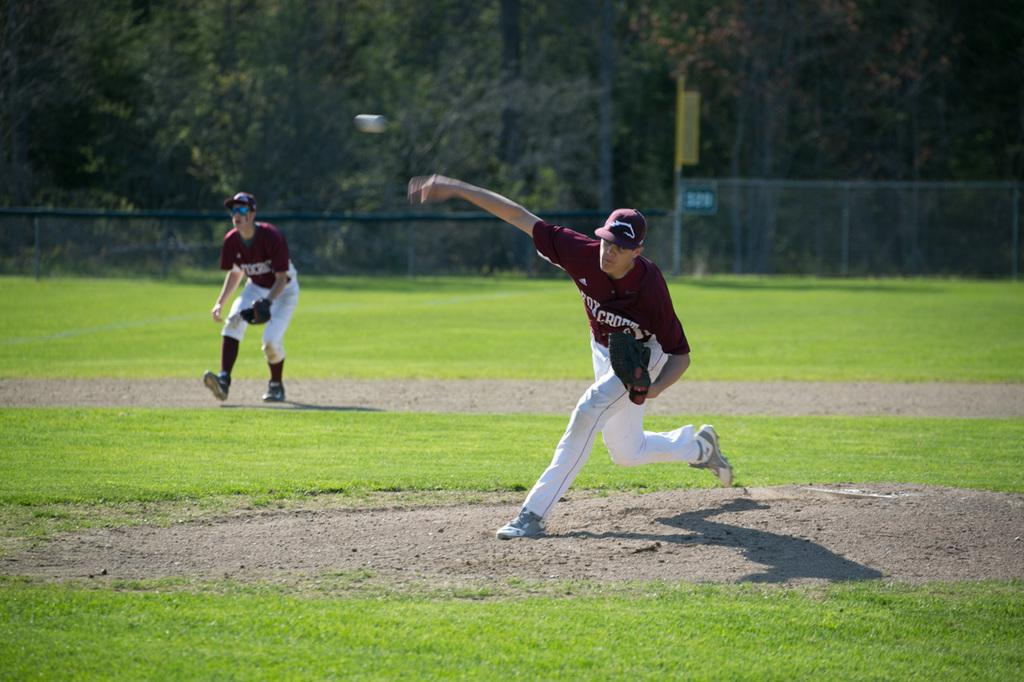How many people are in the image? There are two men in the image. What is the setting of the image? The men are in a grass field. What activity are the men engaged in? One of the men is throwing a ball, and the other man is likely the target of the thrown ball. What type of amusement park ride can be seen in the image? There is no amusement park ride present in the image; it features two men in a grass field. What star is visible in the image? There is no star visible in the image, as it takes place during the day in a grass field. 